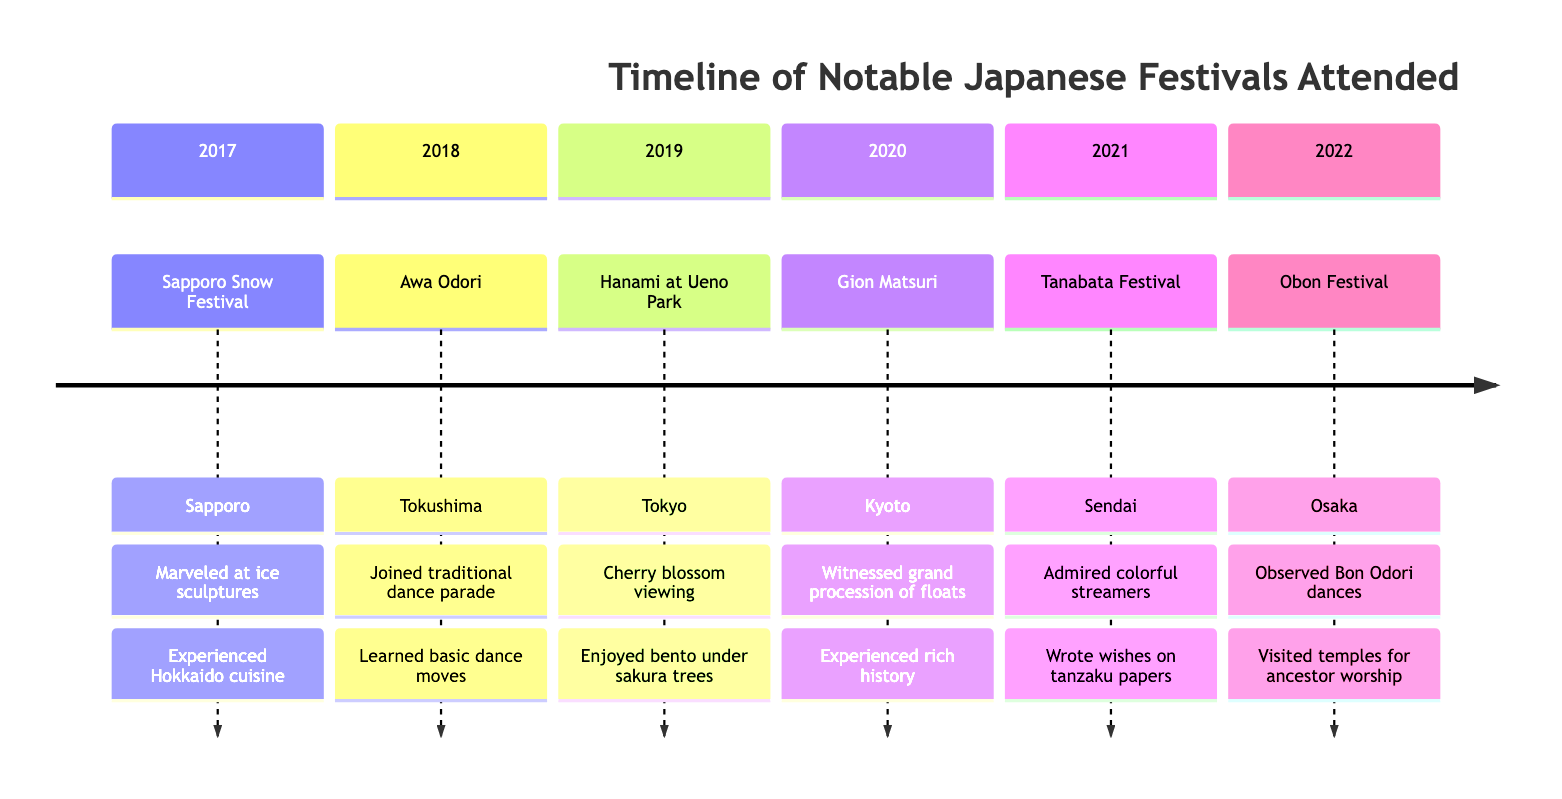What year did the Sapporo Snow Festival take place? The diagram shows that the Sapporo Snow Festival is listed under the section labeled "2017." Therefore, the year of the festival is 2017.
Answer: 2017 What is highlighted about the Awa Odori festival? According to the diagram, the highlights of the Awa Odori festival include joining the traditional dance parade and learning basic dance moves.
Answer: Joined traditional dance parade; learned basic dance moves How many festivals are listed in the timeline? By counting each section in the timeline, we note that there are a total of six festivals, from Sapporo Snow Festival to Obon Festival.
Answer: 6 In which city did Hanami at Ueno Park occur? The diagram indicates that Hanami at Ueno Park took place in Tokyo, as it is listed in the corresponding section for that festival.
Answer: Tokyo What cultural nuance is emphasized during the Obon Festival? The diagram indicates that a key cultural nuance during the Obon Festival is showing respect during ancestor worship rituals, which is highlighted under that section.
Answer: Showing respect during ancestor worship rituals How does the Tanabata Festival allow for personal interaction? The highlights of the Tanabata Festival include participating in writing wishes on tanzaku papers, which allows personal engagement and interaction with the tradition. This point leads us to understand the interaction aspect of the festival through personal expressions of wishes.
Answer: Participated in writing wishes on tanzaku papers What is a significant aspect of experiencing the Gion Matsuri? The diagram notes that a significant aspect of the Gion Matsuri is witnessing the grand procession of floats, which showcases the cultural richness and historical importance of this festival. Therefore, the experience includes observing these cultural displays.
Answer: Witnessed the grand procession of floats What are the types of foods enjoyed during the Tanabata Festival? The diagram lists local festival foods such as yakisoba and taiyaki being enjoyed during the Tanabata Festival, highlighting the culinary aspect of the festival.
Answer: Yakisoba and taiyaki Where does the festival of Hanami take place? The diagram specifies that the Hanami festival occurs in Ueno Park, which is part of Tokyo, indicating the exact location of this annual celebration focused on cherry blossom viewing.
Answer: Ueno Park 